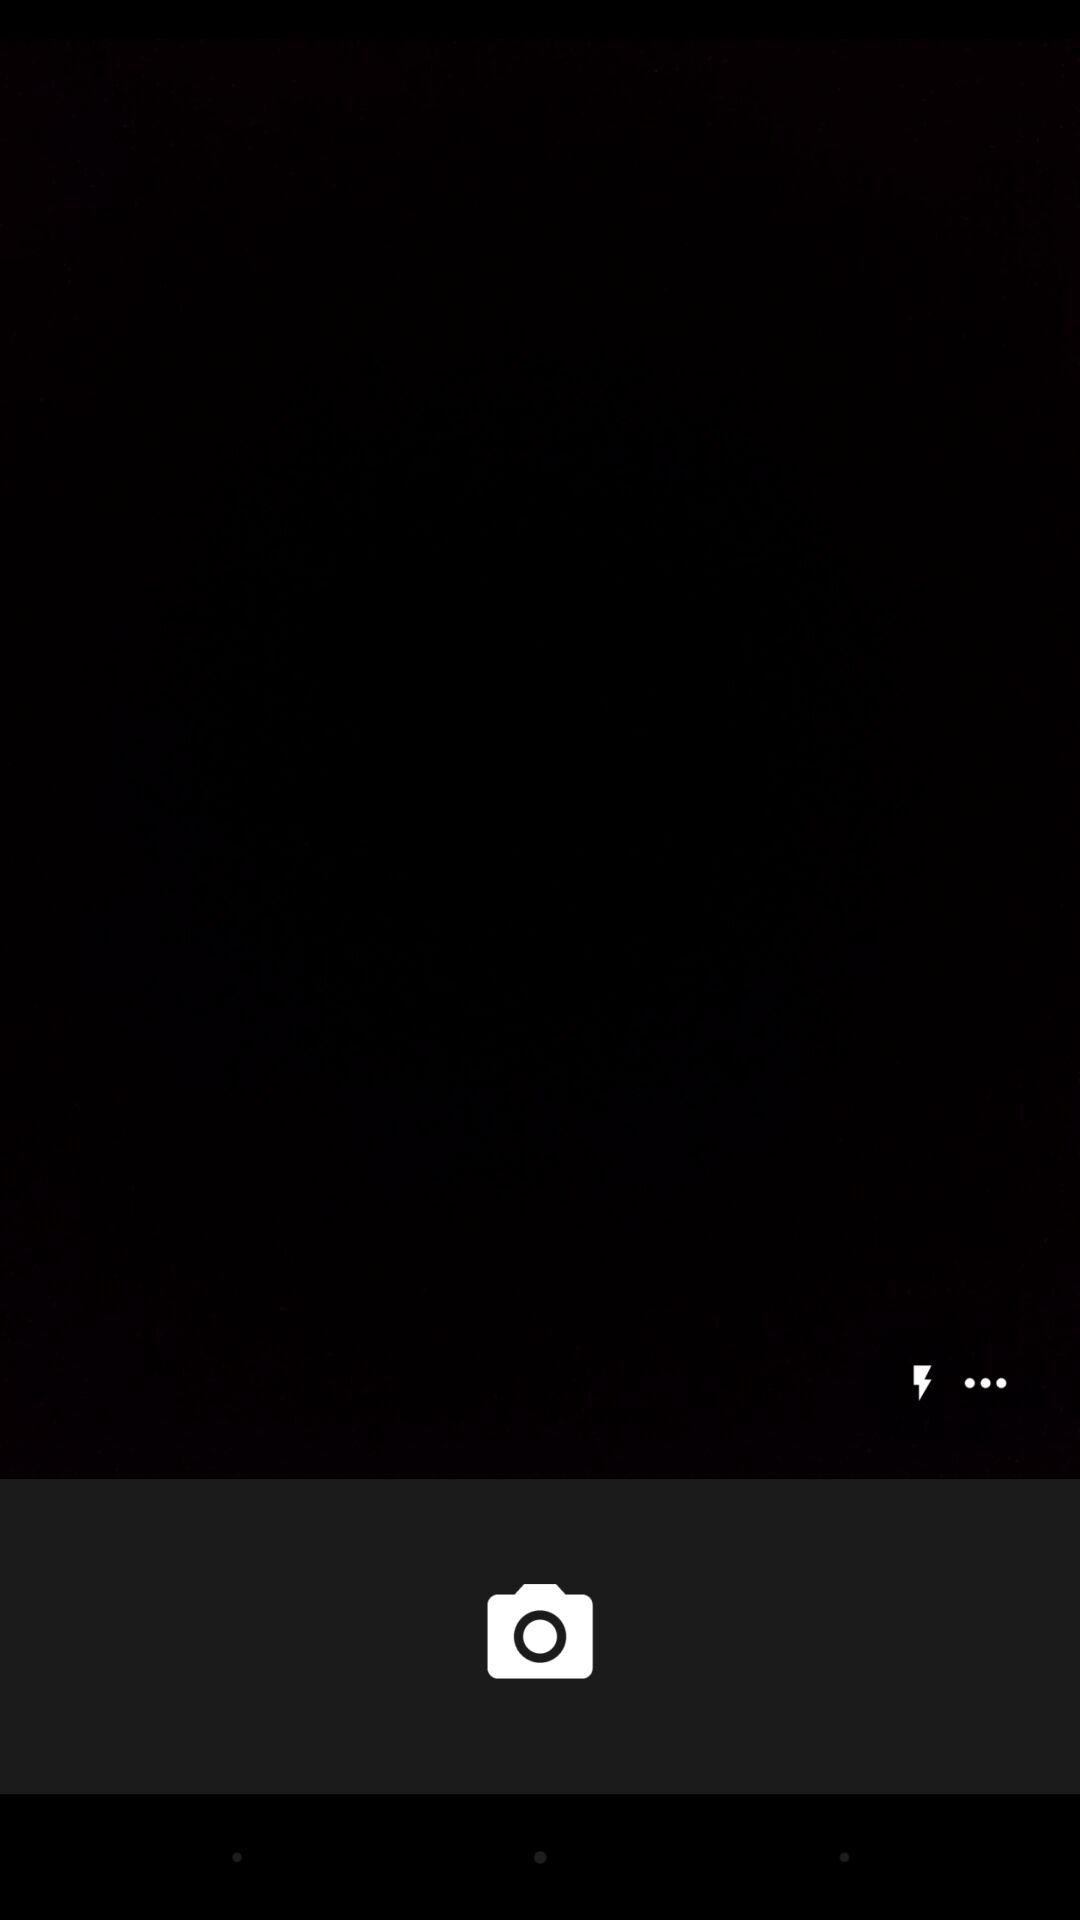How many more dots are there than lightning bolts?
Answer the question using a single word or phrase. 2 